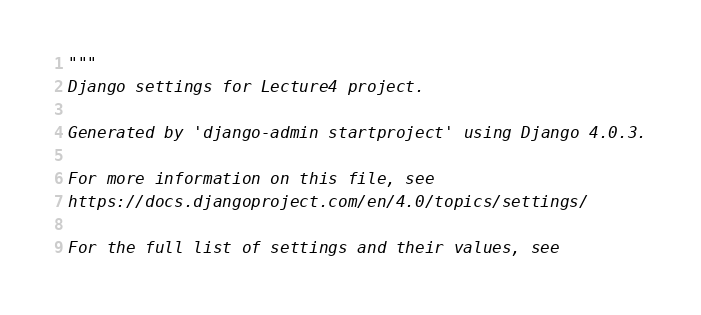Convert code to text. <code><loc_0><loc_0><loc_500><loc_500><_Python_>"""
Django settings for Lecture4 project.

Generated by 'django-admin startproject' using Django 4.0.3.

For more information on this file, see
https://docs.djangoproject.com/en/4.0/topics/settings/

For the full list of settings and their values, see</code> 